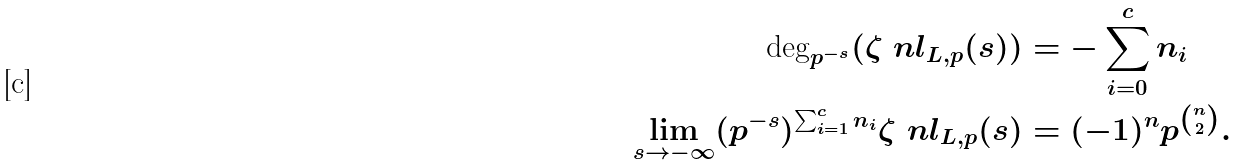Convert formula to latex. <formula><loc_0><loc_0><loc_500><loc_500>\text {deg} _ { p ^ { - s } } ( \zeta ^ { \ } n l _ { L , p } ( s ) ) & = - \sum _ { i = 0 } ^ { c } n _ { i } \\ \lim _ { s \rightarrow - \infty } ( p ^ { - s } ) ^ { \sum _ { i = 1 } ^ { c } n _ { i } } \zeta ^ { \ } n l _ { L , p } ( s ) & = ( - 1 ) ^ { n } p ^ { \binom { n } { 2 } } .</formula> 